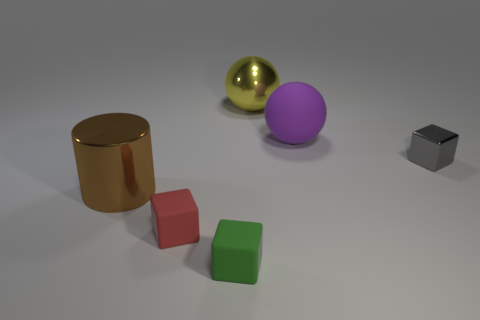What material is the yellow sphere?
Make the answer very short. Metal. There is a gray thing that is the same shape as the red matte thing; what material is it?
Your response must be concise. Metal. There is a large brown metallic cylinder; how many big things are right of it?
Ensure brevity in your answer.  2. Does the purple rubber object have the same shape as the tiny gray object?
Offer a terse response. No. How many objects are both right of the large brown shiny object and to the left of the big shiny ball?
Keep it short and to the point. 2. What number of objects are red matte things or big balls to the left of the large matte ball?
Provide a succinct answer. 2. Are there more metal objects than purple matte balls?
Ensure brevity in your answer.  Yes. There is a large object that is left of the green object; what is its shape?
Make the answer very short. Cylinder. What number of other big objects are the same shape as the red object?
Keep it short and to the point. 0. What is the size of the matte object right of the large shiny thing that is right of the large brown metallic cylinder?
Your answer should be very brief. Large. 